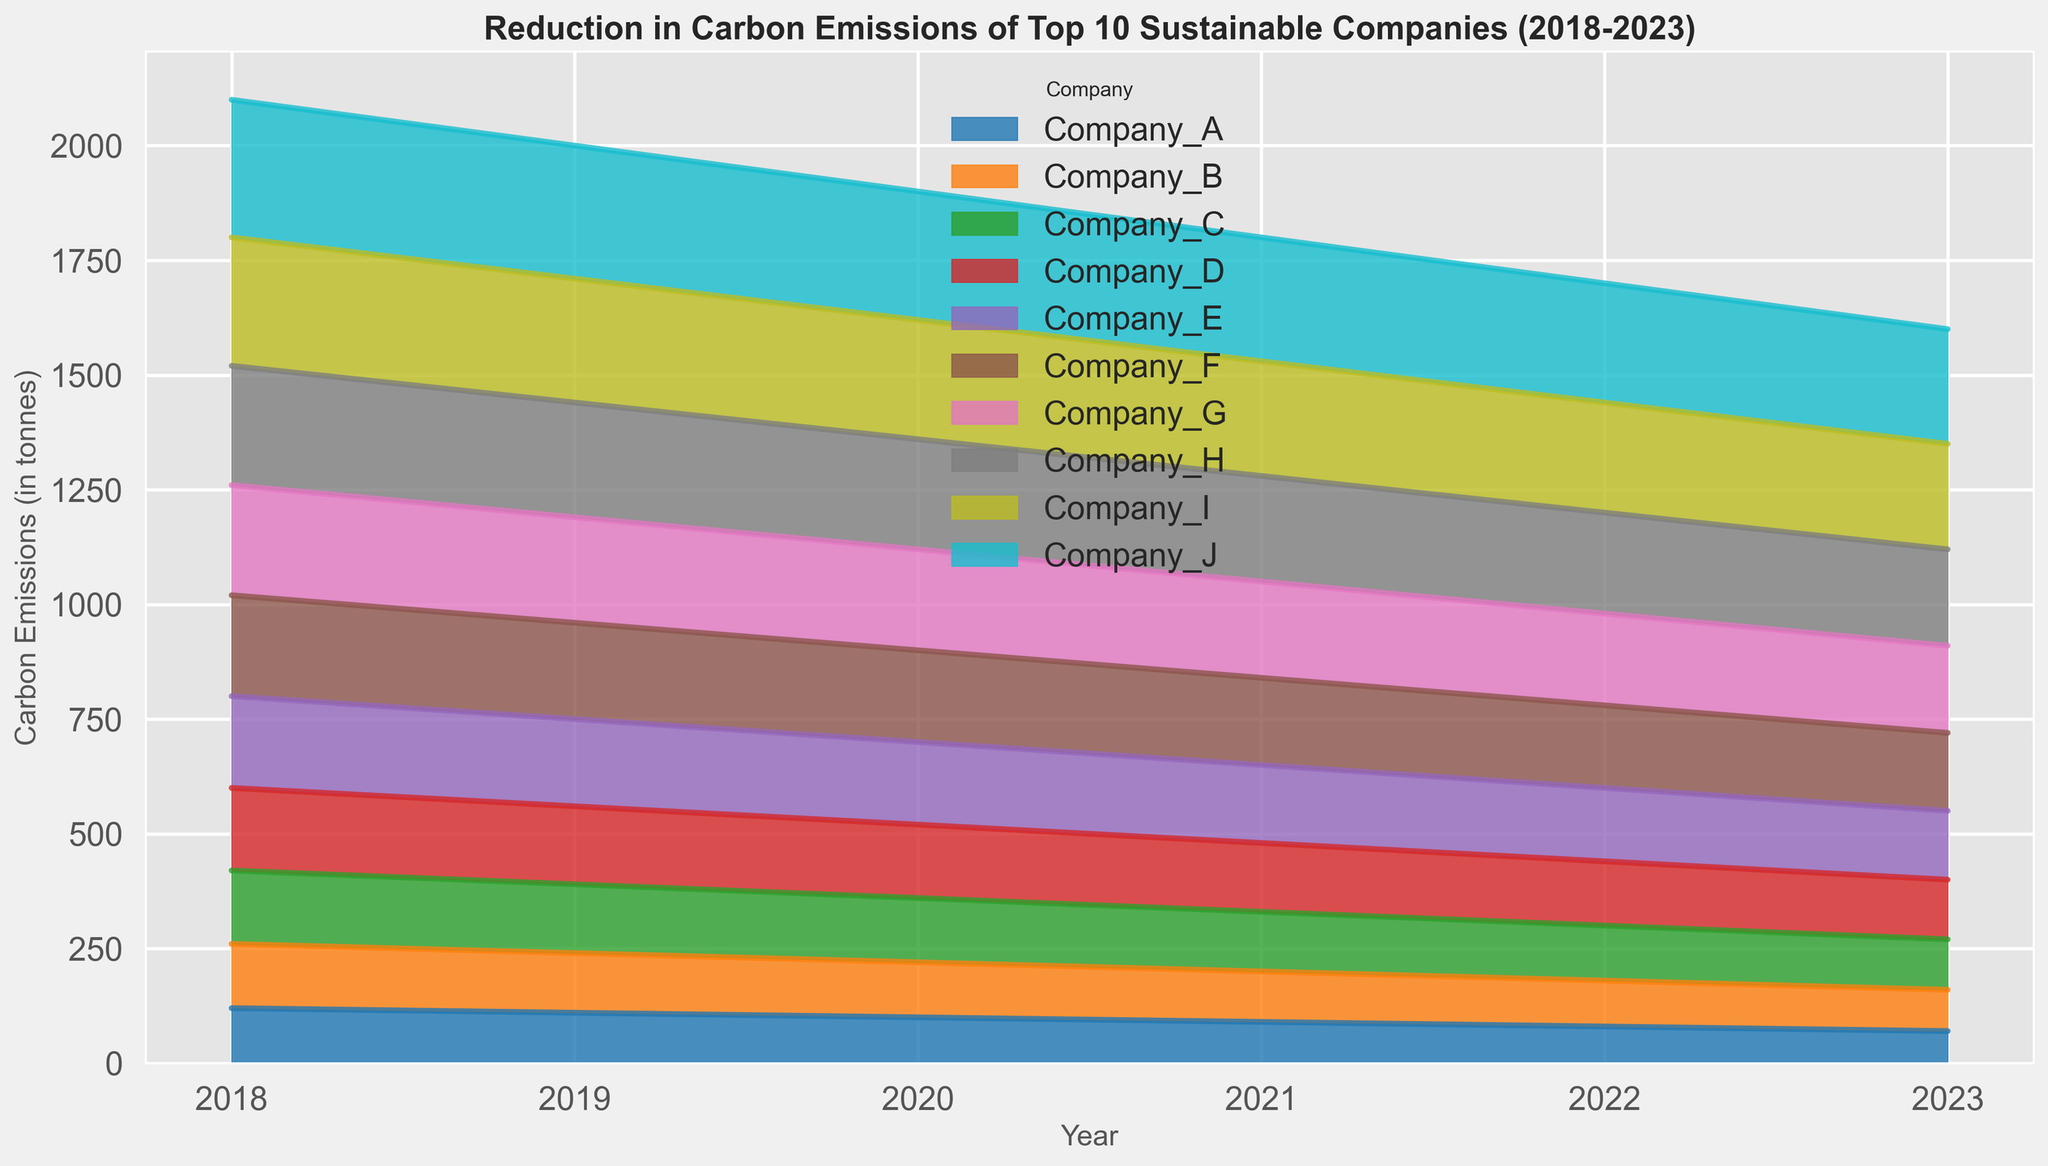What is the overall trend in carbon emissions for Company_A from 2018 to 2023? From 2018 to 2023, the height of the area representing Company_A gradually decreases each year, indicating a consistent reduction in carbon emissions.
Answer: Decreasing Which company had the highest carbon emissions in 2018? By comparing the heights of the areas for all companies in 2018, Company_J has the tallest area in that year.
Answer: Company_J Between Company_C and Company_D, which had a greater reduction in carbon emissions from 2018 to 2023? Looking at the difference in the heights of the areas from 2018 to 2023, Company_C reduces from 160 to 110 (50) and Company_D reduces from 180 to 130 (50). Thus, the reduction is equal.
Answer: Equal How does the carbon emissions reduction of Company_E in 2020 compare to that in 2022? The height of the area decreases from 180 in 2020 to 160 in 2022, showing a reduction of 20 units.
Answer: 20 units By how much did Company_H’s carbon emissions change from 2019 to 2021? In 2019, Company_H’s emissions were 250 and in 2021, they were 230. The difference is 250 - 230 = 20 units.
Answer: 20 units What is the average carbon emissions in 2020 for all companies combined? Sum the heights of all areas in the year 2020 and divide by the number of companies. (120+140+160+180+200+220+240+260+280+300)/10 = 230.
Answer: 230 Which company had the lowest carbon emissions in 2023? By evaluating the lowest area in 2023, Company_A had the lowest emissions with the smallest area height.
Answer: Company_A Are there any companies that did not have a steady decrease in carbon emissions year over year? By visually inspecting the areas, all companies show a consistent year-over-year decrease, indicating none had irregularities.
Answer: None How much total reduction did Company_B achieve from 2018 to 2023? The reduction is calculated by subtracting the emission in 2023 from that in 2018: 140 - 90 = 50.
Answer: 50 Which companies had over 200 units of carbon emissions in 2023? Checking the areas in 2023, Company_H and Company_I had areas above the 200 mark in the height scale.
Answer: Company_H, Company_I 